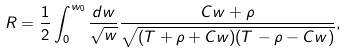Convert formula to latex. <formula><loc_0><loc_0><loc_500><loc_500>R = \frac { 1 } { 2 } \int _ { 0 } ^ { w _ { 0 } } \frac { d w } { \sqrt { w } } \frac { C w + \rho } { \sqrt { ( T + \rho + C w ) ( T - \rho - C w ) } } ,</formula> 